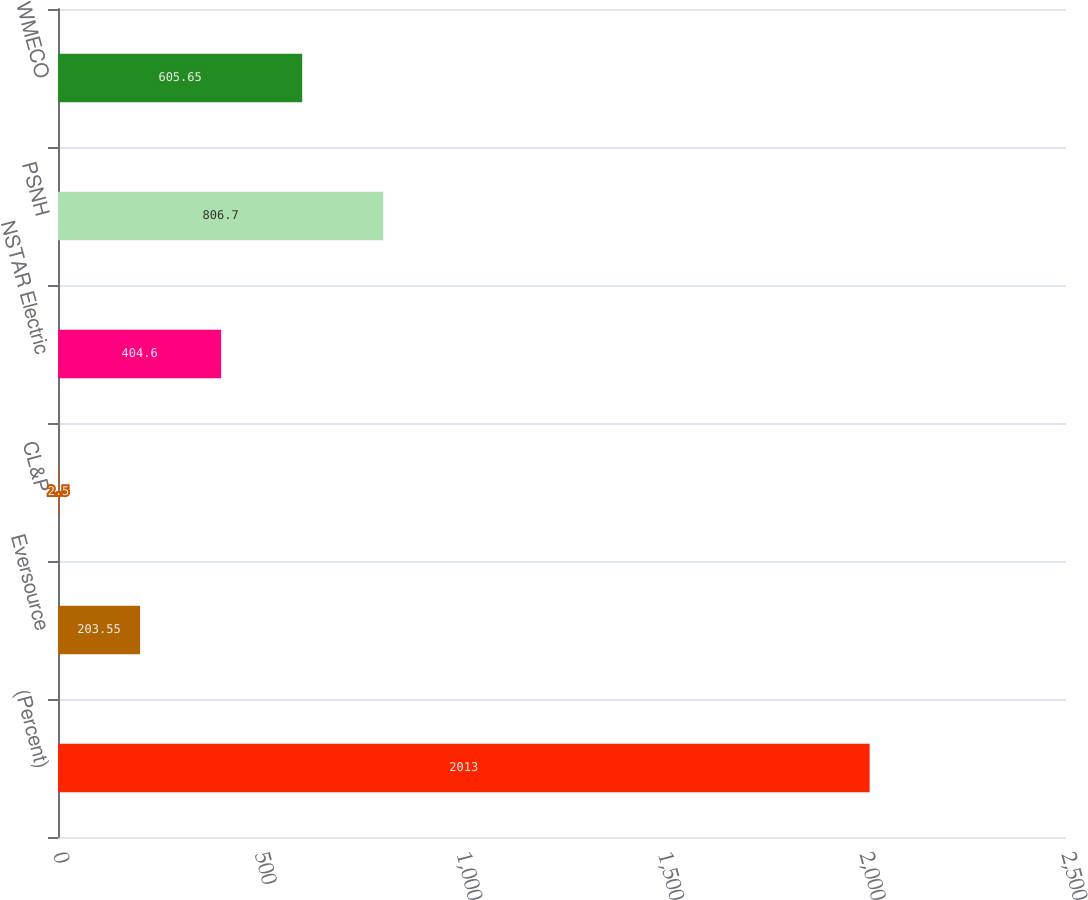Convert chart. <chart><loc_0><loc_0><loc_500><loc_500><bar_chart><fcel>(Percent)<fcel>Eversource<fcel>CL&P<fcel>NSTAR Electric<fcel>PSNH<fcel>WMECO<nl><fcel>2013<fcel>203.55<fcel>2.5<fcel>404.6<fcel>806.7<fcel>605.65<nl></chart> 